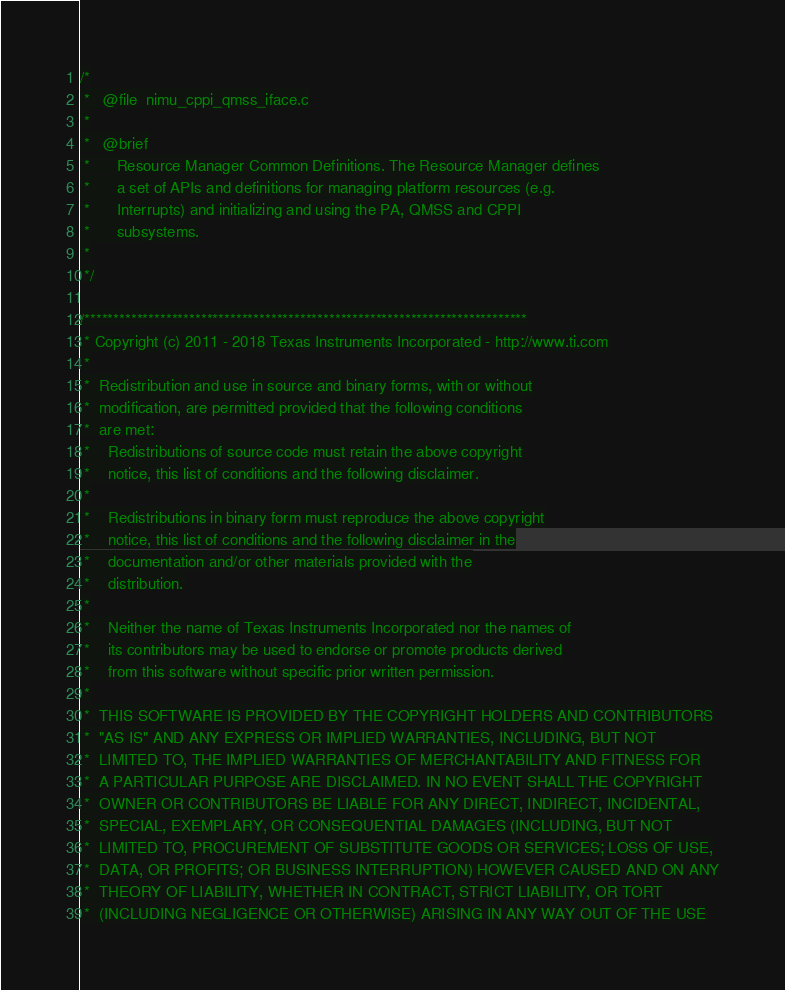<code> <loc_0><loc_0><loc_500><loc_500><_C_>
/*
 *   @file  nimu_cppi_qmss_iface.c
 *
 *   @brief
 *      Resource Manager Common Definitions. The Resource Manager defines
 *		a set of APIs and definitions for managing platform resources (e.g.
 *		Interrupts) and initializing and using the PA, QMSS and CPPI
 *		subsystems.
 *
 */

/****************************************************************************
 * Copyright (c) 2011 - 2018 Texas Instruments Incorporated - http://www.ti.com
 *
 *  Redistribution and use in source and binary forms, with or without
 *  modification, are permitted provided that the following conditions
 *  are met:
 *    Redistributions of source code must retain the above copyright
 *    notice, this list of conditions and the following disclaimer.
 *
 *    Redistributions in binary form must reproduce the above copyright
 *    notice, this list of conditions and the following disclaimer in the
 *    documentation and/or other materials provided with the
 *    distribution.
 *
 *    Neither the name of Texas Instruments Incorporated nor the names of
 *    its contributors may be used to endorse or promote products derived
 *    from this software without specific prior written permission.
 *
 *  THIS SOFTWARE IS PROVIDED BY THE COPYRIGHT HOLDERS AND CONTRIBUTORS
 *  "AS IS" AND ANY EXPRESS OR IMPLIED WARRANTIES, INCLUDING, BUT NOT
 *  LIMITED TO, THE IMPLIED WARRANTIES OF MERCHANTABILITY AND FITNESS FOR
 *  A PARTICULAR PURPOSE ARE DISCLAIMED. IN NO EVENT SHALL THE COPYRIGHT
 *  OWNER OR CONTRIBUTORS BE LIABLE FOR ANY DIRECT, INDIRECT, INCIDENTAL,
 *  SPECIAL, EXEMPLARY, OR CONSEQUENTIAL DAMAGES (INCLUDING, BUT NOT
 *  LIMITED TO, PROCUREMENT OF SUBSTITUTE GOODS OR SERVICES; LOSS OF USE,
 *  DATA, OR PROFITS; OR BUSINESS INTERRUPTION) HOWEVER CAUSED AND ON ANY
 *  THEORY OF LIABILITY, WHETHER IN CONTRACT, STRICT LIABILITY, OR TORT
 *  (INCLUDING NEGLIGENCE OR OTHERWISE) ARISING IN ANY WAY OUT OF THE USE</code> 